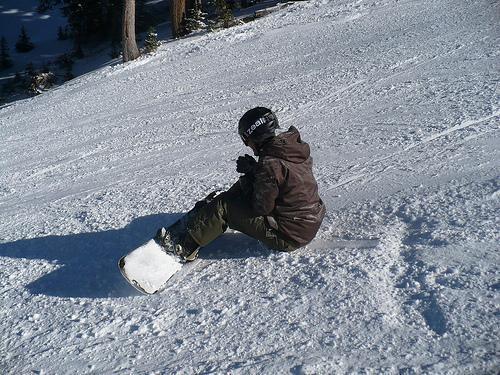How many people are in the picture?
Give a very brief answer. 1. 